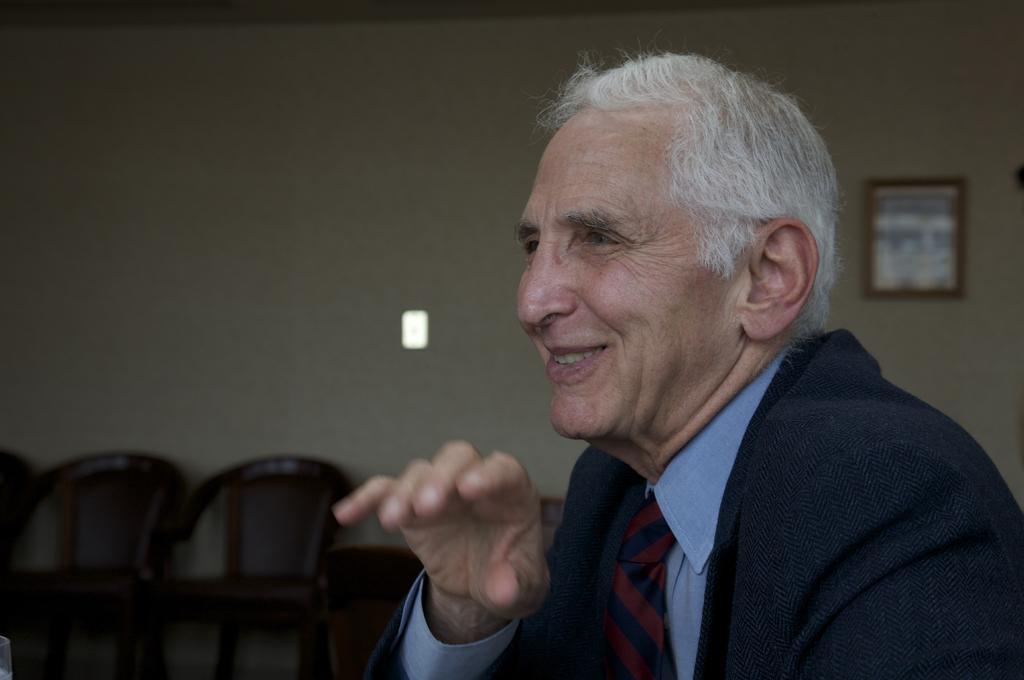Could you give a brief overview of what you see in this image? Here there is a man smiling,behind him there is a wall, chairs and a frame on the wall. 